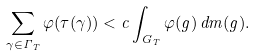<formula> <loc_0><loc_0><loc_500><loc_500>\sum _ { \gamma \in \Gamma _ { T } } \varphi ( \tau ( \gamma ) ) < c \int _ { G _ { T } } \varphi ( g ) \, d m ( g ) .</formula> 